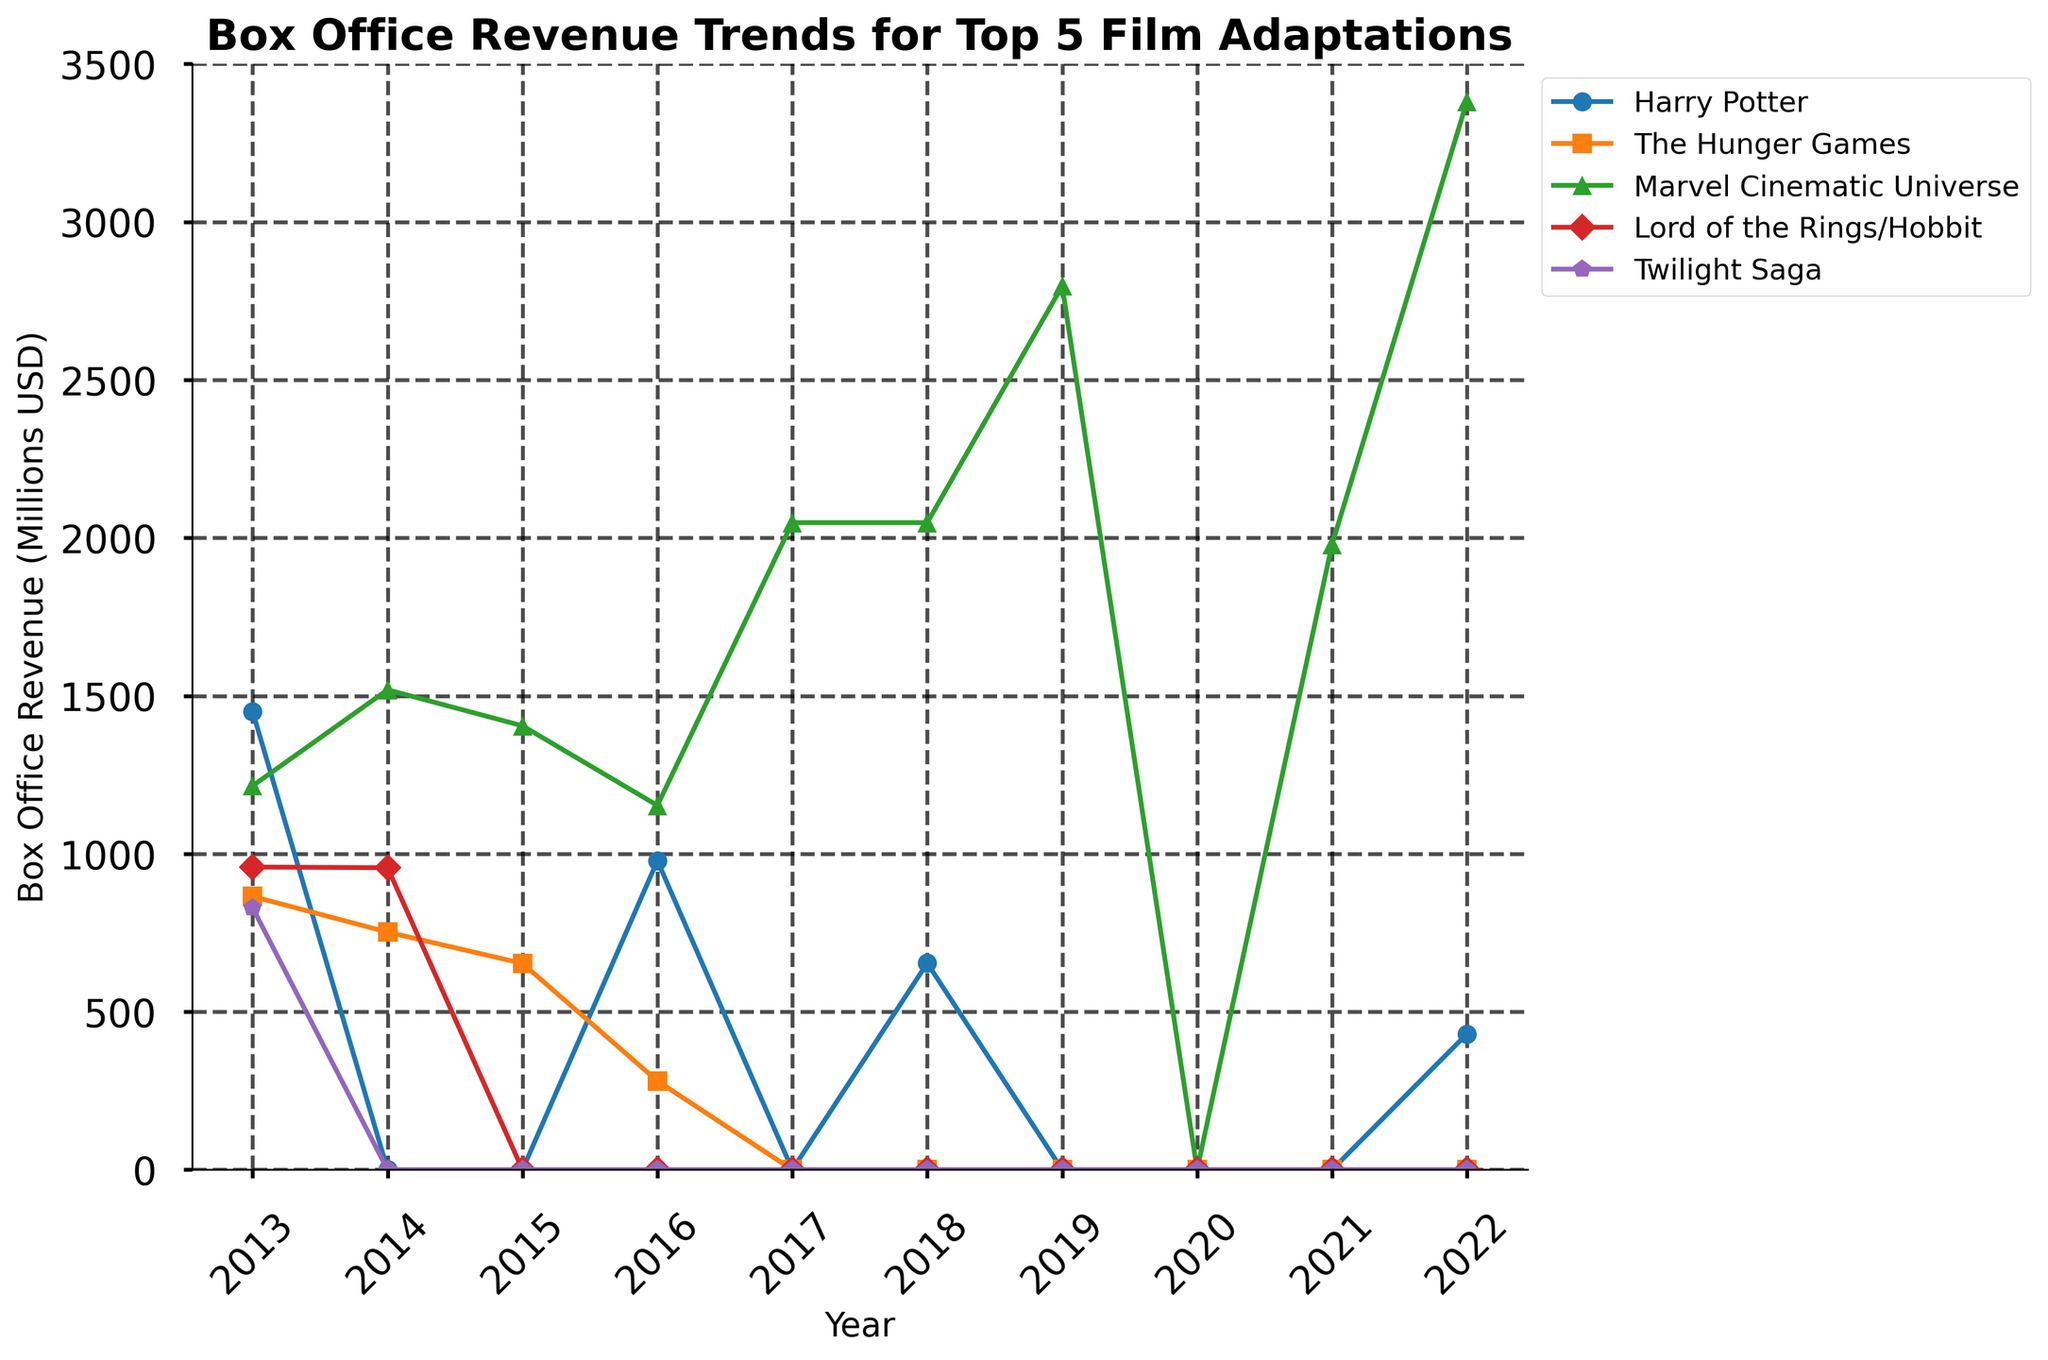Which year had the highest box office revenue for Harry Potter? By examining the line for Harry Potter in the plot, the peak is highest in 2013.
Answer: 2013 How many years did The Hunger Games report significant box office revenue? On the plot, there are two years where The Hunger Games had non-zero values which are 2013 and 2014.
Answer: 2 years Which franchise had the highest box office revenue in 2022? By comparing the five franchise lines at the year 2022, Marvel Cinematic Universe has the highest revenue.
Answer: Marvel Cinematic Universe Between 2013 and 2019, during which years did the Lord of the Rings/Hobbit franchise report box office revenue? Looking at the timeline, the only years with non-zero values for Lord of the Rings/Hobbit are 2013 and 2014.
Answer: 2013 and 2014 What is the total box office revenue for the Twilight Saga from 2013 to 2022? From the plot, the only values for the Twilight Saga are 829 in 2013. Summing them gives 829.
Answer: 829 Which year did Marvel Cinematic Universe reach its peak box office revenue, and what was the amount? Observing the Marvel Cinematic Universe line, the peak occurs in 2022 with a value of 3381.
Answer: 2022, 3381 For which franchise is the revenue trend completely absent after 2013? Examining the lines, Twilight Saga has no values after 2013.
Answer: Twilight Saga Compare the box office revenue of Harry Potter in 2013 and 2016, and calculate the difference. Harry Potter revenues in 2013 and 2016 are 1450 and 978 respectively. The difference is 1450 - 978.
Answer: 472 In 2017 and 2018, which franchise had consistent box office revenue? Only Marvel Cinematic Universe shows non-zero and consistent (2048 each year) values in both 2017 and 2018.
Answer: Marvel Cinematic Universe 